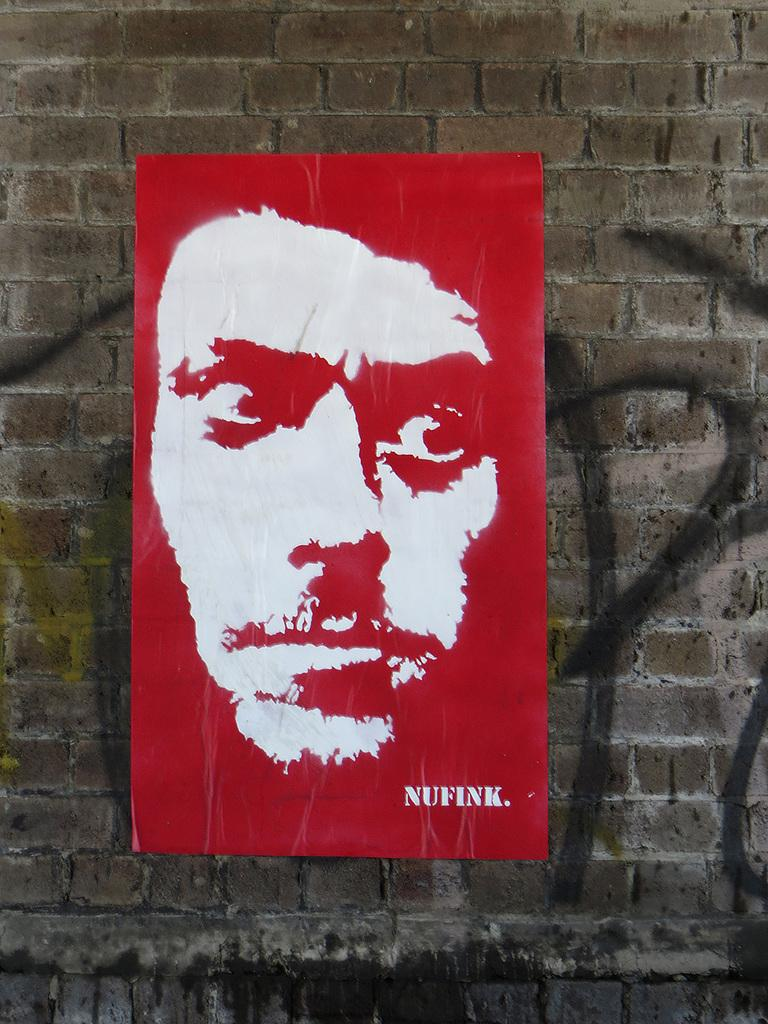Provide a one-sentence caption for the provided image. Nufink has a red and white poster of a man's face on a brick wall. 